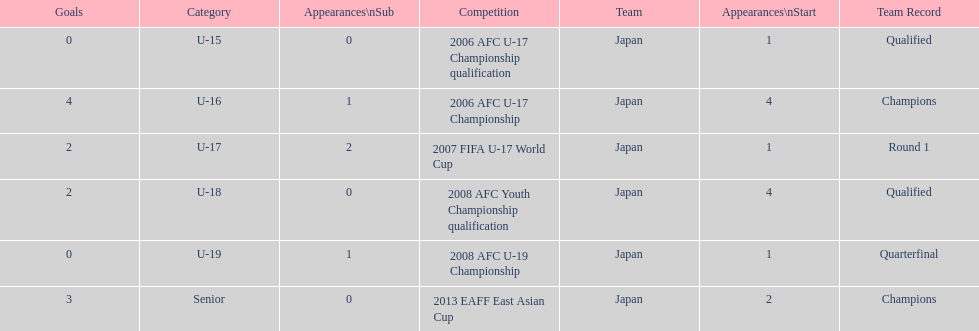How many total goals were scored? 11. 